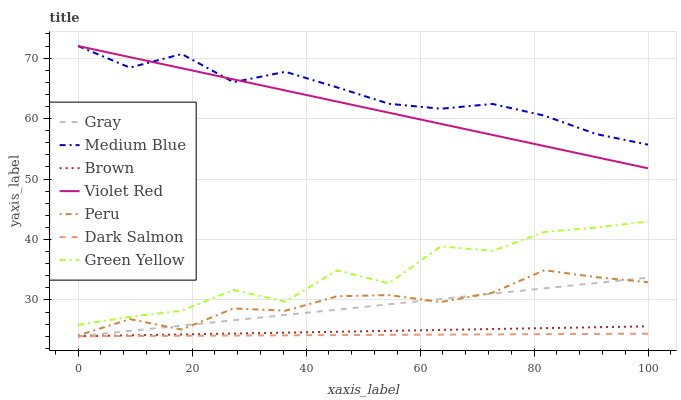Does Dark Salmon have the minimum area under the curve?
Answer yes or no. Yes. Does Medium Blue have the maximum area under the curve?
Answer yes or no. Yes. Does Violet Red have the minimum area under the curve?
Answer yes or no. No. Does Violet Red have the maximum area under the curve?
Answer yes or no. No. Is Brown the smoothest?
Answer yes or no. Yes. Is Green Yellow the roughest?
Answer yes or no. Yes. Is Violet Red the smoothest?
Answer yes or no. No. Is Violet Red the roughest?
Answer yes or no. No. Does Gray have the lowest value?
Answer yes or no. Yes. Does Violet Red have the lowest value?
Answer yes or no. No. Does Medium Blue have the highest value?
Answer yes or no. Yes. Does Brown have the highest value?
Answer yes or no. No. Is Peru less than Violet Red?
Answer yes or no. Yes. Is Medium Blue greater than Peru?
Answer yes or no. Yes. Does Dark Salmon intersect Gray?
Answer yes or no. Yes. Is Dark Salmon less than Gray?
Answer yes or no. No. Is Dark Salmon greater than Gray?
Answer yes or no. No. Does Peru intersect Violet Red?
Answer yes or no. No. 